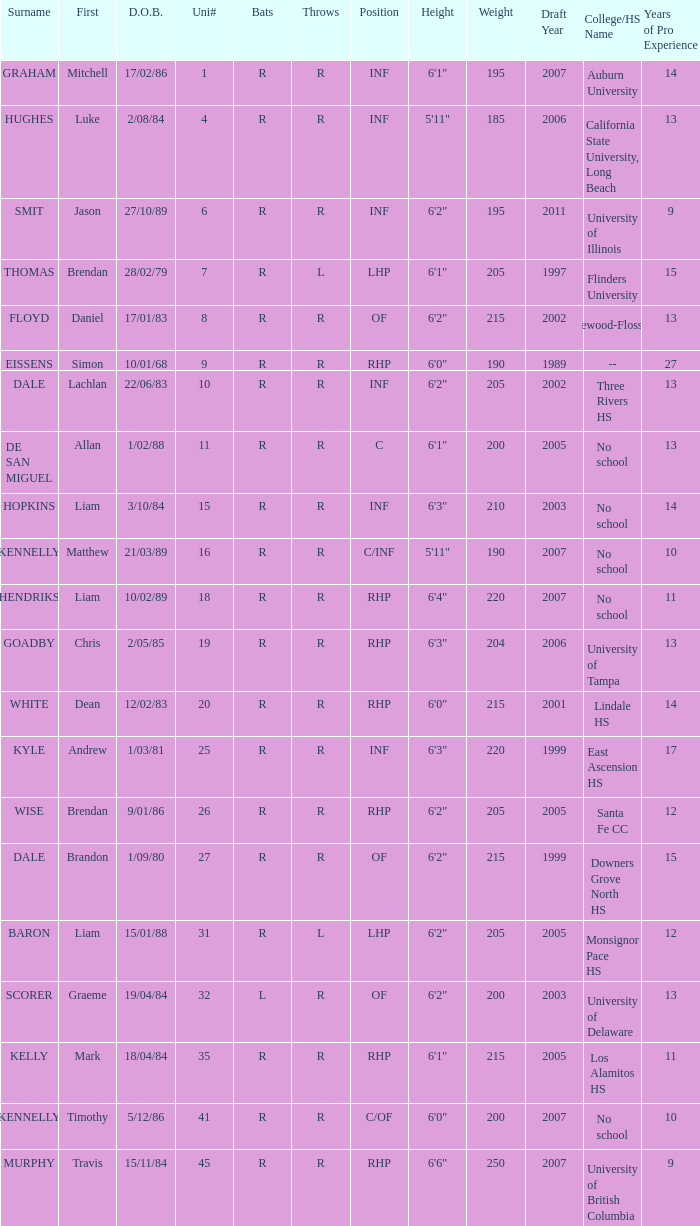Which batsman has a uni# of 31? R. Parse the table in full. {'header': ['Surname', 'First', 'D.O.B.', 'Uni#', 'Bats', 'Throws', 'Position', 'Height', 'Weight', 'Draft Year', 'College/HS Name', 'Years of Pro Experience'], 'rows': [['GRAHAM', 'Mitchell', '17/02/86', '1', 'R', 'R', 'INF', '6\'1"', '195', '2007', 'Auburn University', '14'], ['HUGHES', 'Luke', '2/08/84', '4', 'R', 'R', 'INF', '5\'11"', '185', '2006', 'California State University, Long Beach', '13'], ['SMIT', 'Jason', '27/10/89', '6', 'R', 'R', 'INF', '6\'2"', '195', '2011', 'University of Illinois', '9'], ['THOMAS', 'Brendan', '28/02/79', '7', 'R', 'L', 'LHP', '6\'1"', '205', '1997', 'Flinders University', '15'], ['FLOYD', 'Daniel', '17/01/83', '8', 'R', 'R', 'OF', '6\'2"', '215', '2002', 'Homewood-Flossmoor HS', '13'], ['EISSENS', 'Simon', '10/01/68', '9', 'R', 'R', 'RHP', '6\'0"', '190', '1989', '--', '27'], ['DALE', 'Lachlan', '22/06/83', '10', 'R', 'R', 'INF', '6\'2"', '205', '2002', 'Three Rivers HS', '13'], ['DE SAN MIGUEL', 'Allan', '1/02/88', '11', 'R', 'R', 'C', '6\'1"', '200', '2005', 'No school', '13'], ['HOPKINS', 'Liam', '3/10/84', '15', 'R', 'R', 'INF', '6\'3"', '210', '2003', 'No school', '14'], ['KENNELLY', 'Matthew', '21/03/89', '16', 'R', 'R', 'C/INF', '5\'11"', '190', '2007', 'No school', '10'], ['HENDRIKS', 'Liam', '10/02/89', '18', 'R', 'R', 'RHP', '6\'4"', '220', '2007', 'No school', '11'], ['GOADBY', 'Chris', '2/05/85', '19', 'R', 'R', 'RHP', '6\'3"', '204', '2006', 'University of Tampa', '13'], ['WHITE', 'Dean', '12/02/83', '20', 'R', 'R', 'RHP', '6\'0"', '215', '2001', 'Lindale HS', '14'], ['KYLE', 'Andrew', '1/03/81', '25', 'R', 'R', 'INF', '6\'3"', '220', '1999', 'East Ascension HS', '17'], ['WISE', 'Brendan', '9/01/86', '26', 'R', 'R', 'RHP', '6\'2"', '205', '2005', 'Santa Fe CC', '12'], ['DALE', 'Brandon', '1/09/80', '27', 'R', 'R', 'OF', '6\'2"', '215', '1999', 'Downers Grove North HS', '15'], ['BARON', 'Liam', '15/01/88', '31', 'R', 'L', 'LHP', '6\'2"', '205', '2005', 'Monsignor Pace HS', '12'], ['SCORER', 'Graeme', '19/04/84', '32', 'L', 'R', 'OF', '6\'2"', '200', '2003', 'University of Delaware', '13'], ['KELLY', 'Mark', '18/04/84', '35', 'R', 'R', 'RHP', '6\'1"', '215', '2005', 'Los Alamitos HS', '11'], ['KENNELLY', 'Timothy', '5/12/86', '41', 'R', 'R', 'C/OF', '6\'0"', '200', '2007', 'No school', '10'], ['MURPHY', 'Travis', '15/11/84', '45', 'R', 'R', 'RHP', '6\'6"', '250', '2007', 'University of British Columbia', '9']]} 